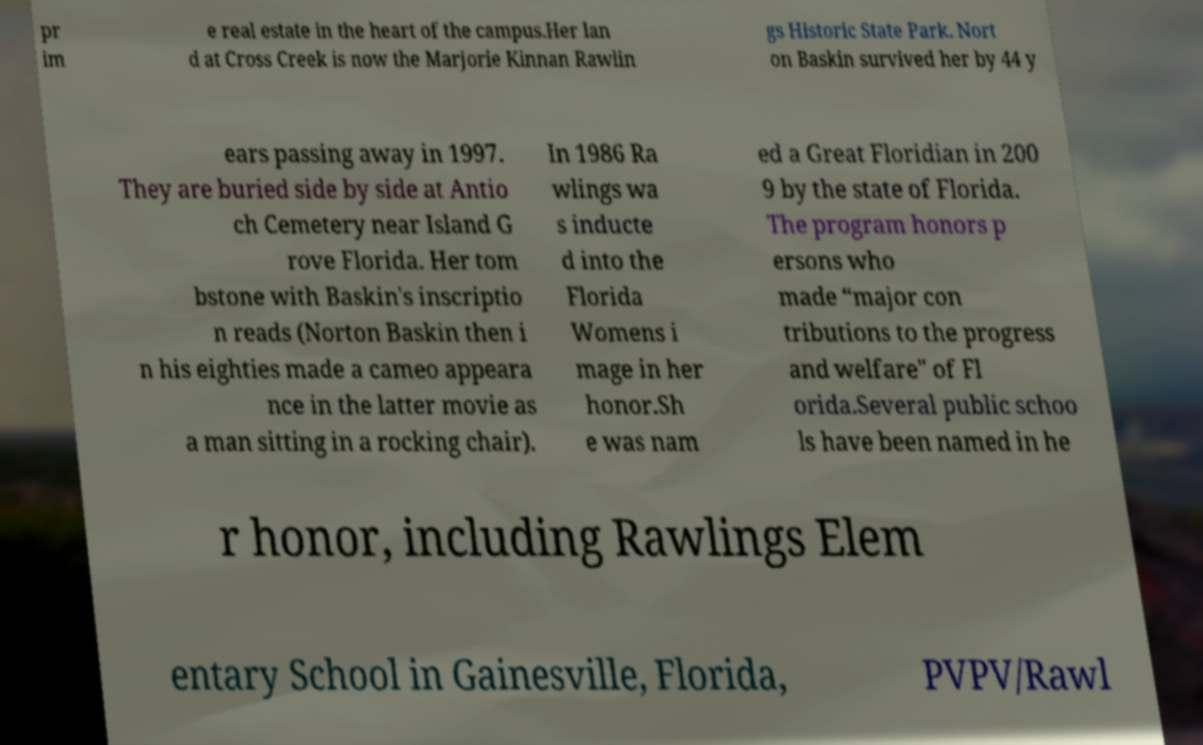Please read and relay the text visible in this image. What does it say? pr im e real estate in the heart of the campus.Her lan d at Cross Creek is now the Marjorie Kinnan Rawlin gs Historic State Park. Nort on Baskin survived her by 44 y ears passing away in 1997. They are buried side by side at Antio ch Cemetery near Island G rove Florida. Her tom bstone with Baskin's inscriptio n reads (Norton Baskin then i n his eighties made a cameo appeara nce in the latter movie as a man sitting in a rocking chair). In 1986 Ra wlings wa s inducte d into the Florida Womens i mage in her honor.Sh e was nam ed a Great Floridian in 200 9 by the state of Florida. The program honors p ersons who made “major con tributions to the progress and welfare" of Fl orida.Several public schoo ls have been named in he r honor, including Rawlings Elem entary School in Gainesville, Florida, PVPV/Rawl 